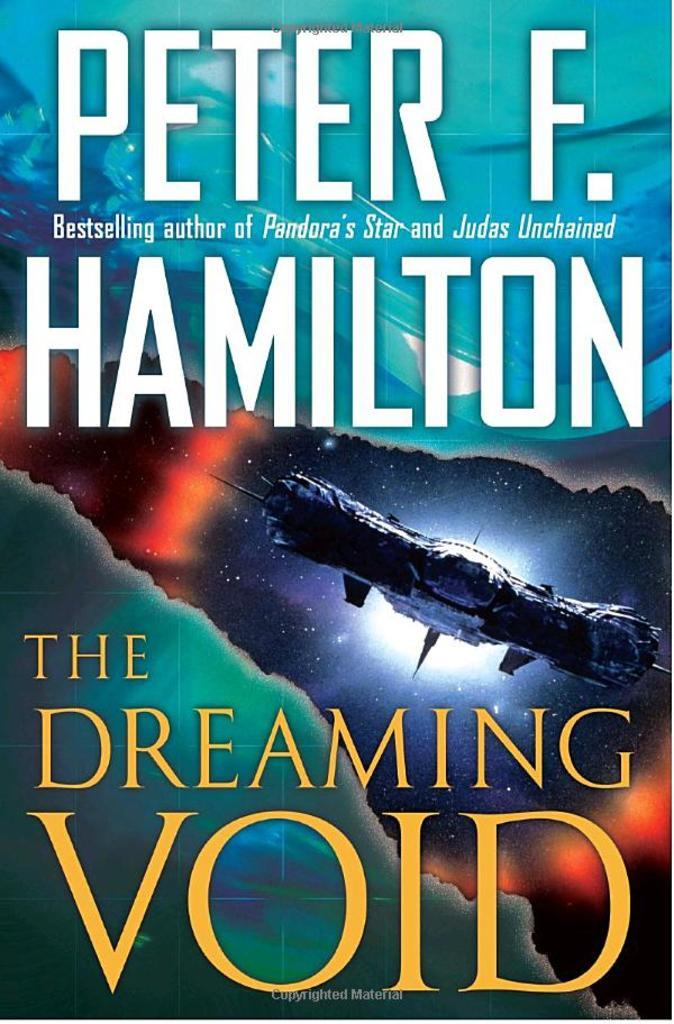<image>
Present a compact description of the photo's key features. A book by Peter F. Hamilton called The Dreaming Void. 